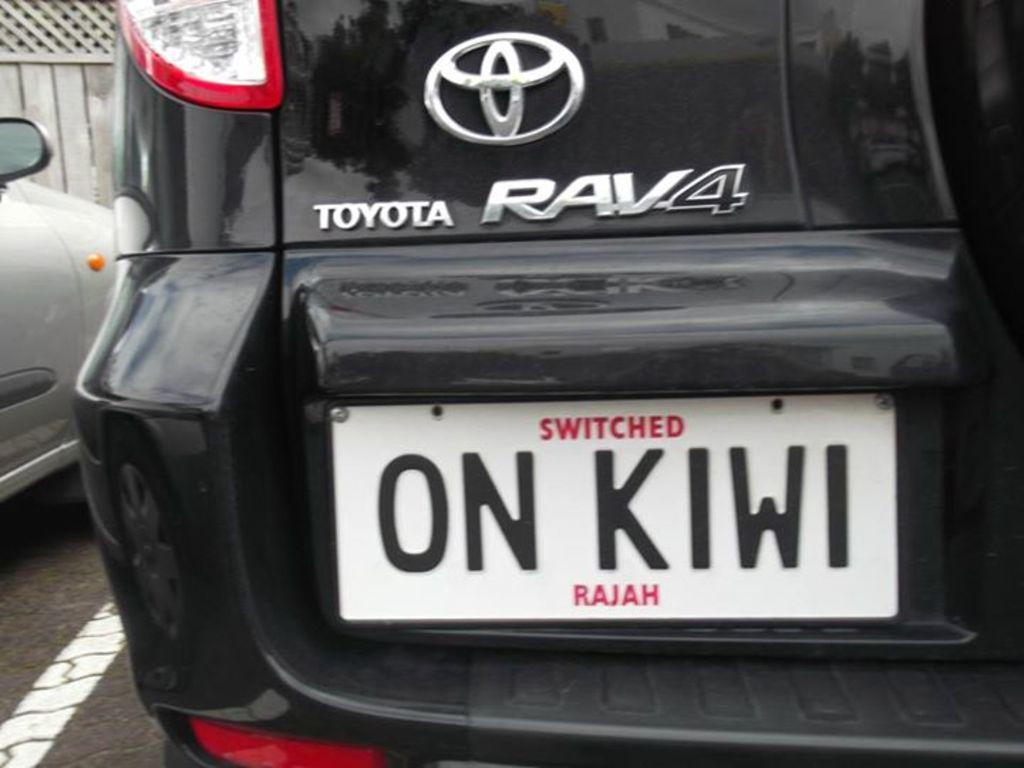<image>
Create a compact narrative representing the image presented. White license plate with black letters which says ON KIWI. 